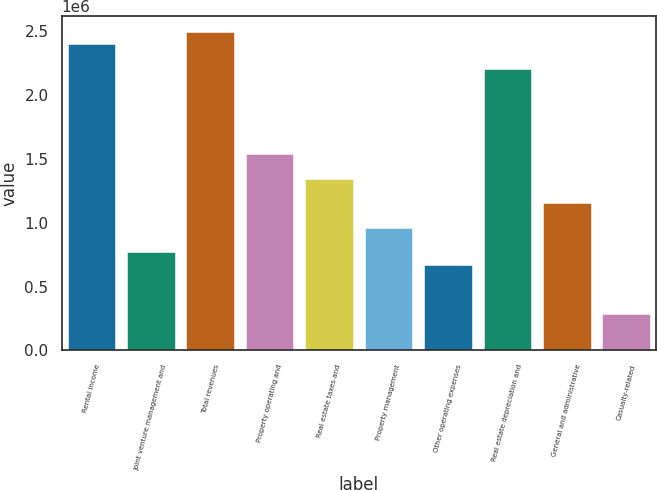<chart> <loc_0><loc_0><loc_500><loc_500><bar_chart><fcel>Rental income<fcel>Joint venture management and<fcel>Total revenues<fcel>Property operating and<fcel>Real estate taxes and<fcel>Property management<fcel>Other operating expenses<fcel>Real estate depreciation and<fcel>General and administrative<fcel>Casualty-related<nl><fcel>2.39965e+06<fcel>767889<fcel>2.49564e+06<fcel>1.53578e+06<fcel>1.3438e+06<fcel>959861<fcel>671903<fcel>2.20768e+06<fcel>1.15183e+06<fcel>287959<nl></chart> 